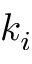Convert formula to latex. <formula><loc_0><loc_0><loc_500><loc_500>k _ { i }</formula> 